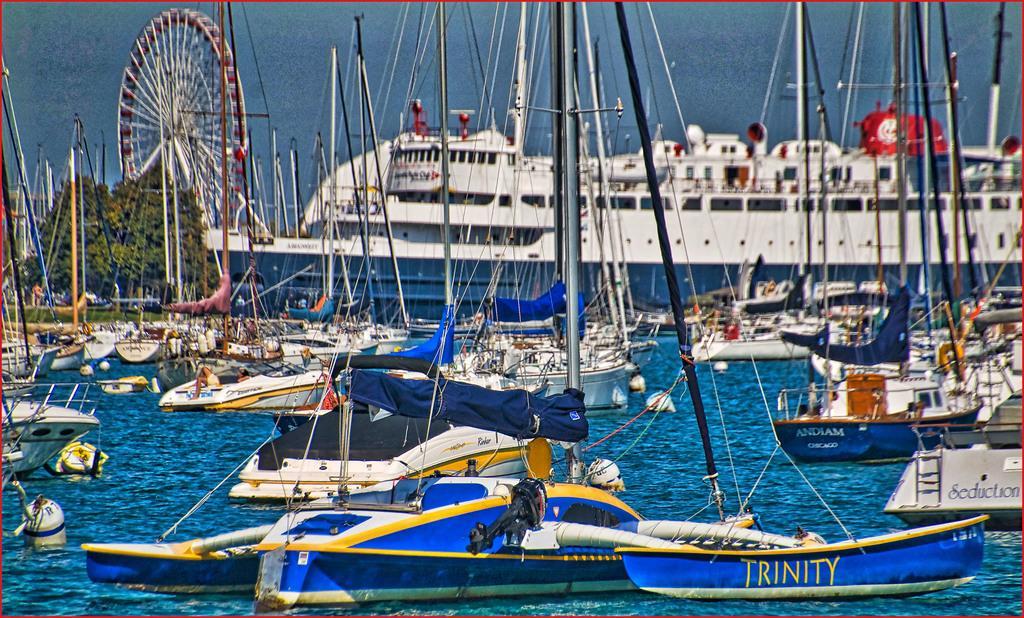How would you summarize this image in a sentence or two? In the foreground of the picture there are boats, ship, trees, people and a ferris wheel. In the foreground there is water. In the background there is water. 